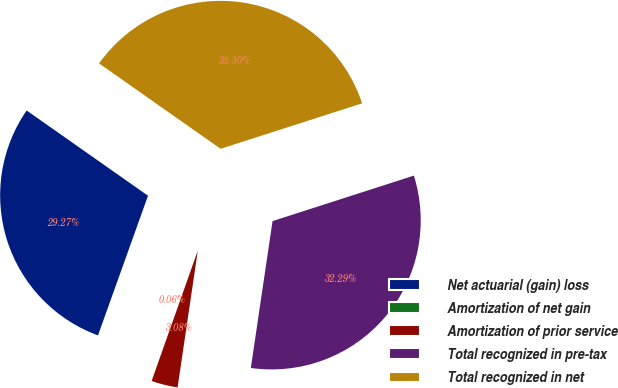Convert chart to OTSL. <chart><loc_0><loc_0><loc_500><loc_500><pie_chart><fcel>Net actuarial (gain) loss<fcel>Amortization of net gain<fcel>Amortization of prior service<fcel>Total recognized in pre-tax<fcel>Total recognized in net<nl><fcel>29.27%<fcel>0.06%<fcel>3.08%<fcel>32.29%<fcel>35.3%<nl></chart> 